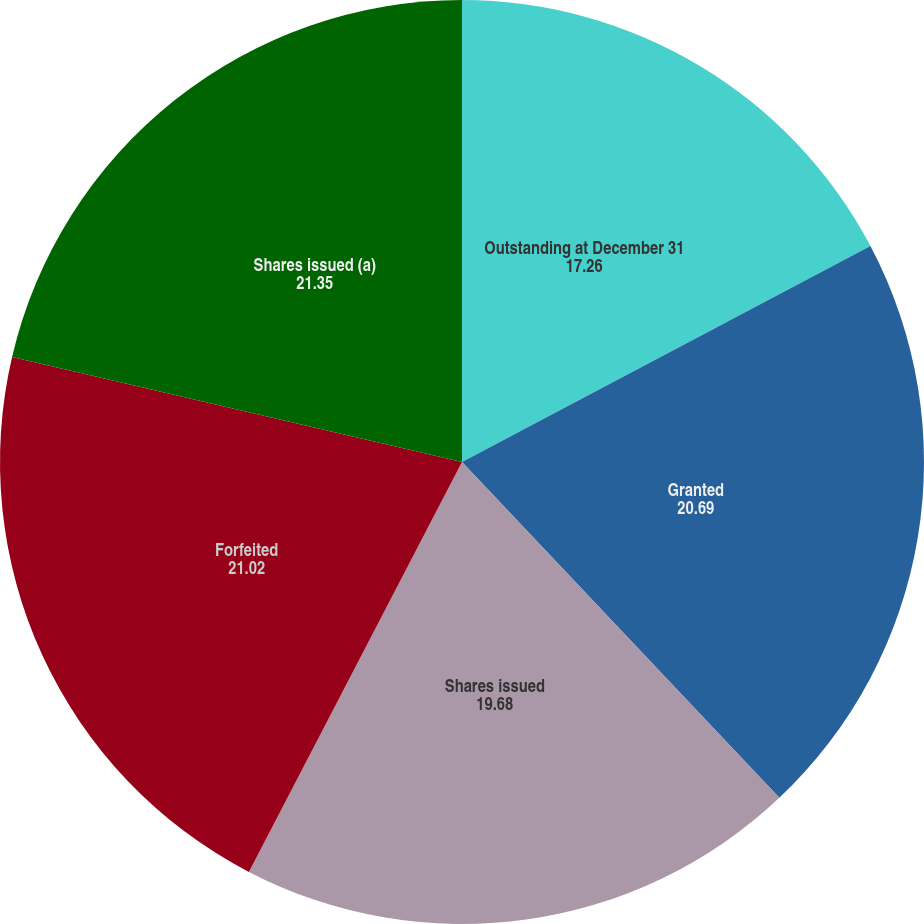Convert chart to OTSL. <chart><loc_0><loc_0><loc_500><loc_500><pie_chart><fcel>Outstanding at December 31<fcel>Granted<fcel>Shares issued<fcel>Forfeited<fcel>Shares issued (a)<nl><fcel>17.26%<fcel>20.69%<fcel>19.68%<fcel>21.02%<fcel>21.35%<nl></chart> 